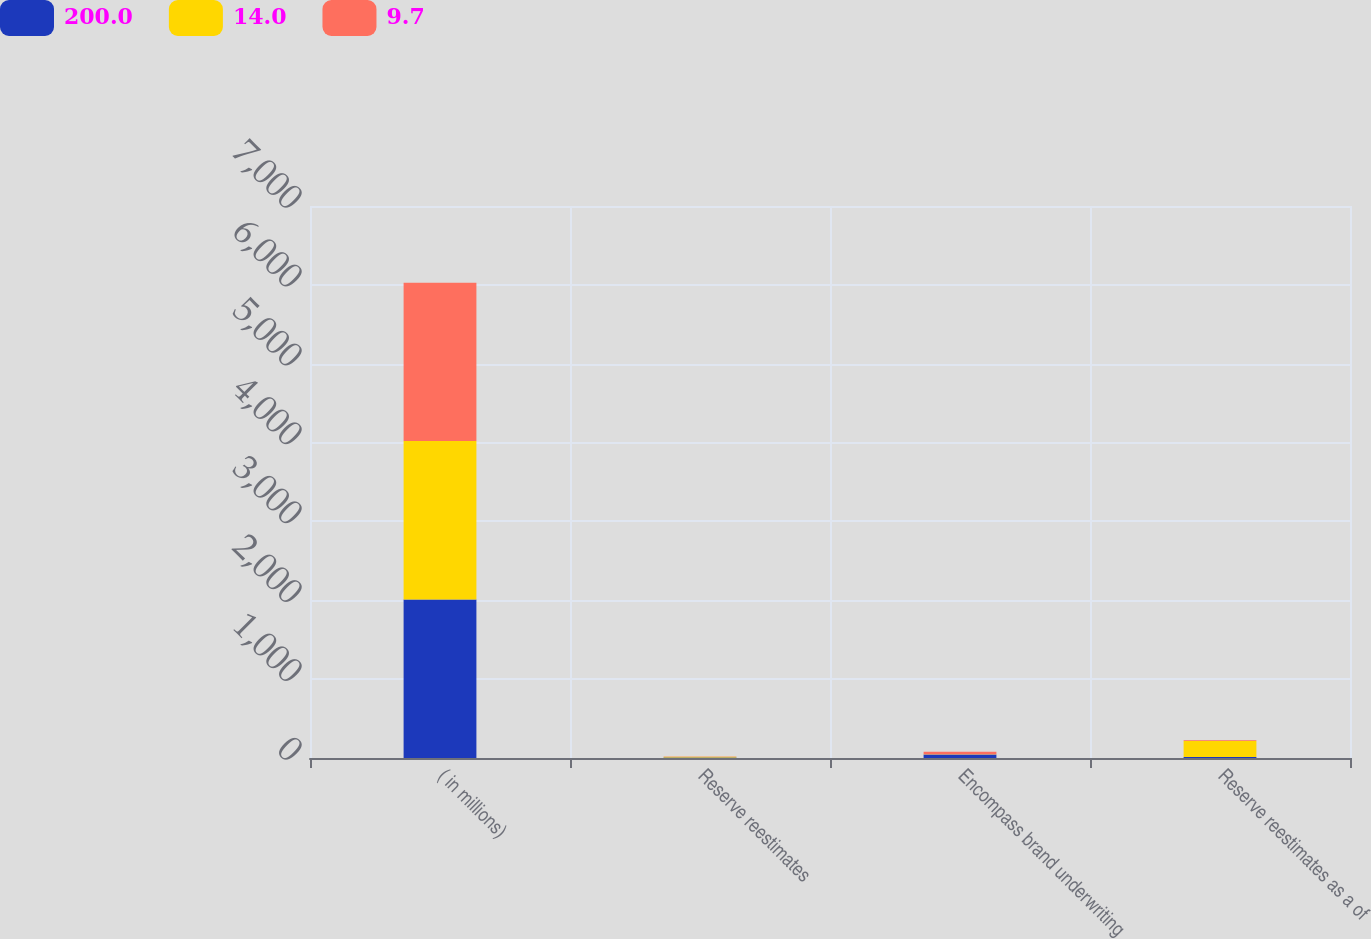Convert chart. <chart><loc_0><loc_0><loc_500><loc_500><stacked_bar_chart><ecel><fcel>( in millions)<fcel>Reserve reestimates<fcel>Encompass brand underwriting<fcel>Reserve reestimates as a of<nl><fcel>200<fcel>2010<fcel>6<fcel>43<fcel>14<nl><fcel>14<fcel>2009<fcel>10<fcel>5<fcel>200<nl><fcel>9.7<fcel>2008<fcel>3<fcel>31<fcel>9.7<nl></chart> 